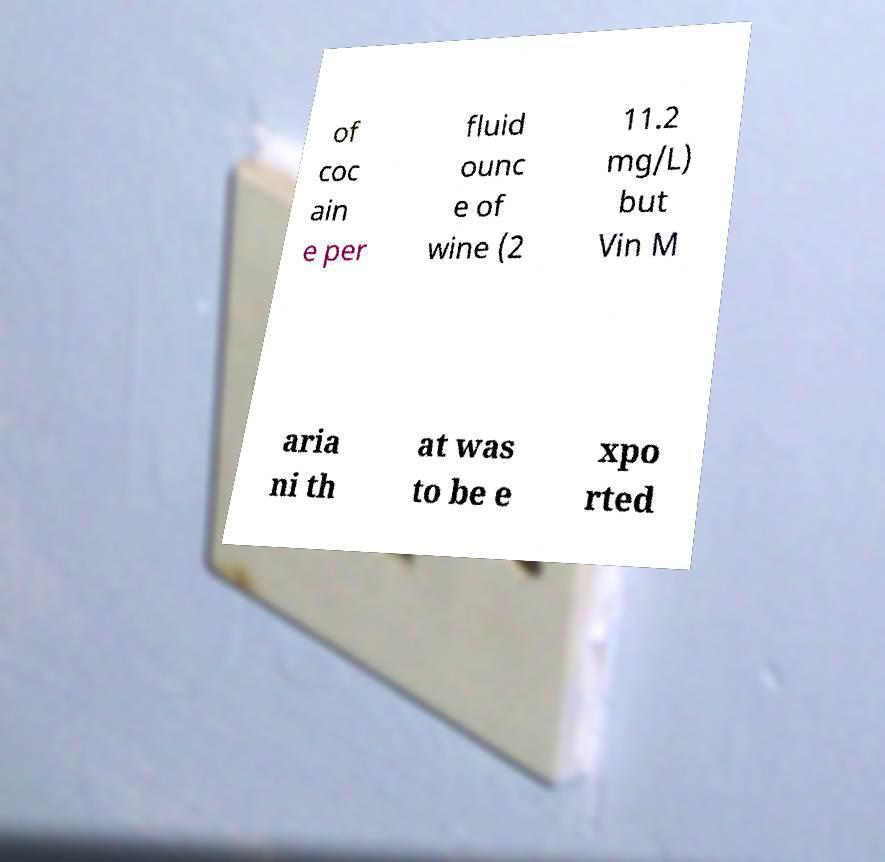What messages or text are displayed in this image? I need them in a readable, typed format. of coc ain e per fluid ounc e of wine (2 11.2 mg/L) but Vin M aria ni th at was to be e xpo rted 